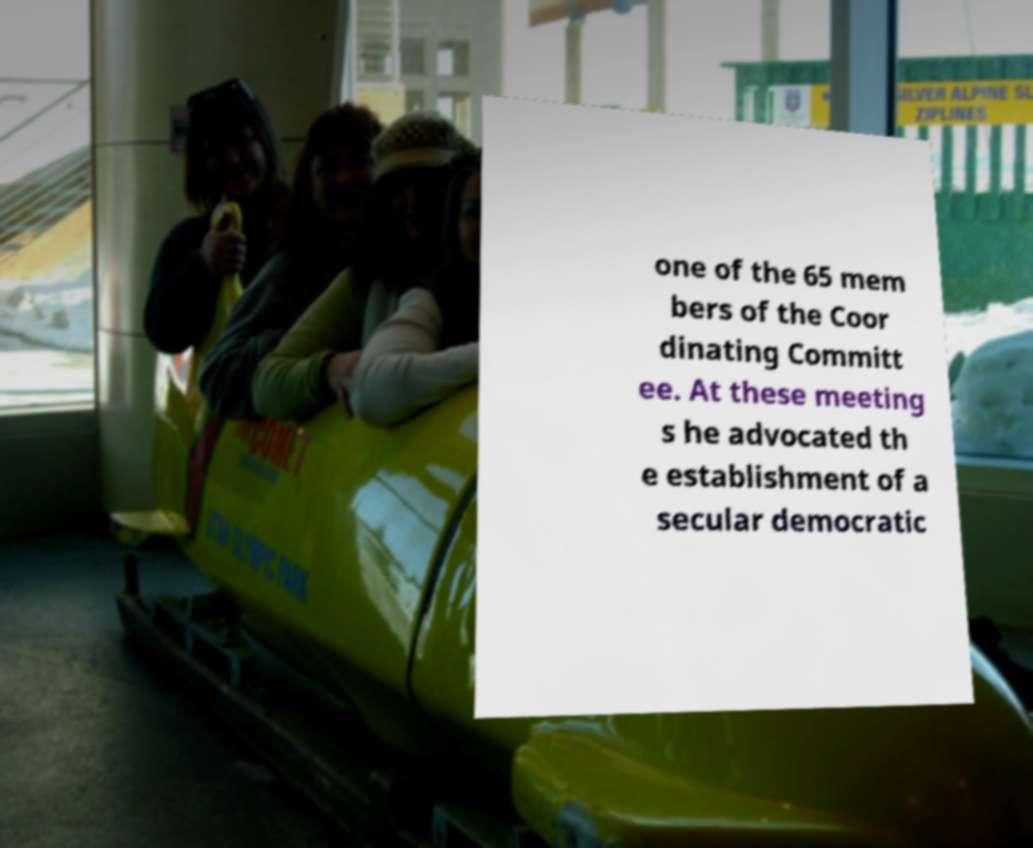Could you assist in decoding the text presented in this image and type it out clearly? one of the 65 mem bers of the Coor dinating Committ ee. At these meeting s he advocated th e establishment of a secular democratic 